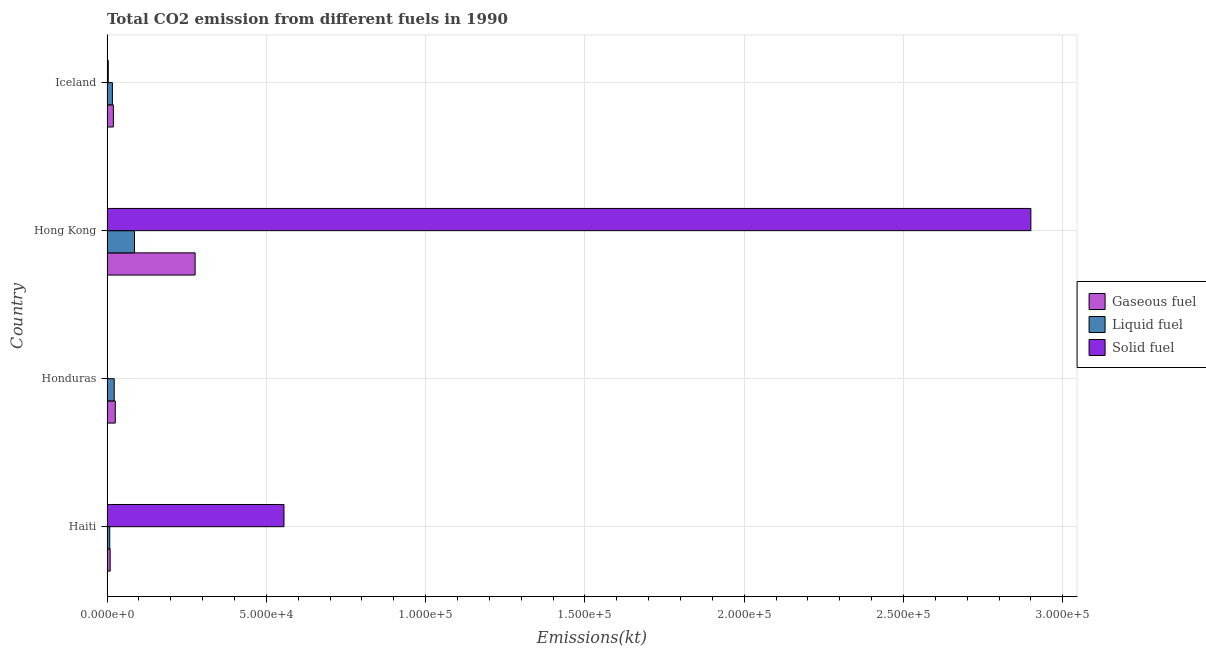How many different coloured bars are there?
Offer a terse response. 3. How many groups of bars are there?
Provide a succinct answer. 4. Are the number of bars on each tick of the Y-axis equal?
Offer a terse response. Yes. How many bars are there on the 3rd tick from the bottom?
Provide a succinct answer. 3. What is the label of the 1st group of bars from the top?
Provide a succinct answer. Iceland. What is the amount of co2 emissions from gaseous fuel in Honduras?
Your answer should be compact. 2592.57. Across all countries, what is the maximum amount of co2 emissions from liquid fuel?
Your answer should be compact. 8632.12. Across all countries, what is the minimum amount of co2 emissions from liquid fuel?
Ensure brevity in your answer.  861.75. In which country was the amount of co2 emissions from gaseous fuel maximum?
Your answer should be very brief. Hong Kong. In which country was the amount of co2 emissions from solid fuel minimum?
Your answer should be very brief. Honduras. What is the total amount of co2 emissions from solid fuel in the graph?
Provide a short and direct response. 3.46e+05. What is the difference between the amount of co2 emissions from gaseous fuel in Haiti and that in Hong Kong?
Offer a terse response. -2.67e+04. What is the difference between the amount of co2 emissions from liquid fuel in Honduras and the amount of co2 emissions from gaseous fuel in Haiti?
Offer a very short reply. 1272.45. What is the average amount of co2 emissions from solid fuel per country?
Provide a short and direct response. 8.65e+04. What is the difference between the amount of co2 emissions from liquid fuel and amount of co2 emissions from gaseous fuel in Haiti?
Your answer should be very brief. -132.01. What is the ratio of the amount of co2 emissions from gaseous fuel in Haiti to that in Honduras?
Your response must be concise. 0.38. Is the amount of co2 emissions from gaseous fuel in Haiti less than that in Hong Kong?
Your answer should be very brief. Yes. What is the difference between the highest and the second highest amount of co2 emissions from solid fuel?
Keep it short and to the point. 2.34e+05. What is the difference between the highest and the lowest amount of co2 emissions from liquid fuel?
Your response must be concise. 7770.37. In how many countries, is the amount of co2 emissions from solid fuel greater than the average amount of co2 emissions from solid fuel taken over all countries?
Ensure brevity in your answer.  1. What does the 1st bar from the top in Honduras represents?
Provide a succinct answer. Solid fuel. What does the 2nd bar from the bottom in Iceland represents?
Ensure brevity in your answer.  Liquid fuel. Is it the case that in every country, the sum of the amount of co2 emissions from gaseous fuel and amount of co2 emissions from liquid fuel is greater than the amount of co2 emissions from solid fuel?
Offer a terse response. No. How many bars are there?
Provide a short and direct response. 12. How many countries are there in the graph?
Offer a very short reply. 4. Are the values on the major ticks of X-axis written in scientific E-notation?
Provide a succinct answer. Yes. Does the graph contain grids?
Give a very brief answer. Yes. How are the legend labels stacked?
Keep it short and to the point. Vertical. What is the title of the graph?
Give a very brief answer. Total CO2 emission from different fuels in 1990. Does "Agriculture" appear as one of the legend labels in the graph?
Your answer should be very brief. No. What is the label or title of the X-axis?
Provide a succinct answer. Emissions(kt). What is the label or title of the Y-axis?
Ensure brevity in your answer.  Country. What is the Emissions(kt) in Gaseous fuel in Haiti?
Your answer should be very brief. 993.76. What is the Emissions(kt) in Liquid fuel in Haiti?
Make the answer very short. 861.75. What is the Emissions(kt) in Solid fuel in Haiti?
Offer a terse response. 5.56e+04. What is the Emissions(kt) of Gaseous fuel in Honduras?
Your response must be concise. 2592.57. What is the Emissions(kt) of Liquid fuel in Honduras?
Keep it short and to the point. 2266.21. What is the Emissions(kt) of Solid fuel in Honduras?
Offer a very short reply. 139.35. What is the Emissions(kt) of Gaseous fuel in Hong Kong?
Keep it short and to the point. 2.77e+04. What is the Emissions(kt) of Liquid fuel in Hong Kong?
Provide a succinct answer. 8632.12. What is the Emissions(kt) of Solid fuel in Hong Kong?
Keep it short and to the point. 2.90e+05. What is the Emissions(kt) in Gaseous fuel in Iceland?
Provide a succinct answer. 1998.52. What is the Emissions(kt) in Liquid fuel in Iceland?
Make the answer very short. 1694.15. What is the Emissions(kt) in Solid fuel in Iceland?
Ensure brevity in your answer.  403.37. Across all countries, what is the maximum Emissions(kt) of Gaseous fuel?
Ensure brevity in your answer.  2.77e+04. Across all countries, what is the maximum Emissions(kt) of Liquid fuel?
Make the answer very short. 8632.12. Across all countries, what is the maximum Emissions(kt) of Solid fuel?
Ensure brevity in your answer.  2.90e+05. Across all countries, what is the minimum Emissions(kt) in Gaseous fuel?
Ensure brevity in your answer.  993.76. Across all countries, what is the minimum Emissions(kt) in Liquid fuel?
Make the answer very short. 861.75. Across all countries, what is the minimum Emissions(kt) in Solid fuel?
Offer a very short reply. 139.35. What is the total Emissions(kt) of Gaseous fuel in the graph?
Your answer should be compact. 3.32e+04. What is the total Emissions(kt) of Liquid fuel in the graph?
Keep it short and to the point. 1.35e+04. What is the total Emissions(kt) in Solid fuel in the graph?
Your response must be concise. 3.46e+05. What is the difference between the Emissions(kt) in Gaseous fuel in Haiti and that in Honduras?
Provide a succinct answer. -1598.81. What is the difference between the Emissions(kt) in Liquid fuel in Haiti and that in Honduras?
Your response must be concise. -1404.46. What is the difference between the Emissions(kt) of Solid fuel in Haiti and that in Honduras?
Ensure brevity in your answer.  5.54e+04. What is the difference between the Emissions(kt) of Gaseous fuel in Haiti and that in Hong Kong?
Make the answer very short. -2.67e+04. What is the difference between the Emissions(kt) of Liquid fuel in Haiti and that in Hong Kong?
Make the answer very short. -7770.37. What is the difference between the Emissions(kt) in Solid fuel in Haiti and that in Hong Kong?
Offer a terse response. -2.34e+05. What is the difference between the Emissions(kt) of Gaseous fuel in Haiti and that in Iceland?
Your response must be concise. -1004.76. What is the difference between the Emissions(kt) in Liquid fuel in Haiti and that in Iceland?
Provide a short and direct response. -832.41. What is the difference between the Emissions(kt) in Solid fuel in Haiti and that in Iceland?
Your answer should be very brief. 5.51e+04. What is the difference between the Emissions(kt) in Gaseous fuel in Honduras and that in Hong Kong?
Your response must be concise. -2.51e+04. What is the difference between the Emissions(kt) of Liquid fuel in Honduras and that in Hong Kong?
Make the answer very short. -6365.91. What is the difference between the Emissions(kt) in Solid fuel in Honduras and that in Hong Kong?
Provide a succinct answer. -2.90e+05. What is the difference between the Emissions(kt) in Gaseous fuel in Honduras and that in Iceland?
Your answer should be very brief. 594.05. What is the difference between the Emissions(kt) of Liquid fuel in Honduras and that in Iceland?
Offer a terse response. 572.05. What is the difference between the Emissions(kt) in Solid fuel in Honduras and that in Iceland?
Ensure brevity in your answer.  -264.02. What is the difference between the Emissions(kt) of Gaseous fuel in Hong Kong and that in Iceland?
Ensure brevity in your answer.  2.57e+04. What is the difference between the Emissions(kt) in Liquid fuel in Hong Kong and that in Iceland?
Provide a short and direct response. 6937.96. What is the difference between the Emissions(kt) of Solid fuel in Hong Kong and that in Iceland?
Offer a terse response. 2.90e+05. What is the difference between the Emissions(kt) of Gaseous fuel in Haiti and the Emissions(kt) of Liquid fuel in Honduras?
Ensure brevity in your answer.  -1272.45. What is the difference between the Emissions(kt) in Gaseous fuel in Haiti and the Emissions(kt) in Solid fuel in Honduras?
Your answer should be very brief. 854.41. What is the difference between the Emissions(kt) in Liquid fuel in Haiti and the Emissions(kt) in Solid fuel in Honduras?
Ensure brevity in your answer.  722.4. What is the difference between the Emissions(kt) in Gaseous fuel in Haiti and the Emissions(kt) in Liquid fuel in Hong Kong?
Provide a succinct answer. -7638.36. What is the difference between the Emissions(kt) in Gaseous fuel in Haiti and the Emissions(kt) in Solid fuel in Hong Kong?
Offer a terse response. -2.89e+05. What is the difference between the Emissions(kt) in Liquid fuel in Haiti and the Emissions(kt) in Solid fuel in Hong Kong?
Ensure brevity in your answer.  -2.89e+05. What is the difference between the Emissions(kt) in Gaseous fuel in Haiti and the Emissions(kt) in Liquid fuel in Iceland?
Make the answer very short. -700.4. What is the difference between the Emissions(kt) of Gaseous fuel in Haiti and the Emissions(kt) of Solid fuel in Iceland?
Offer a very short reply. 590.39. What is the difference between the Emissions(kt) of Liquid fuel in Haiti and the Emissions(kt) of Solid fuel in Iceland?
Offer a very short reply. 458.38. What is the difference between the Emissions(kt) of Gaseous fuel in Honduras and the Emissions(kt) of Liquid fuel in Hong Kong?
Offer a very short reply. -6039.55. What is the difference between the Emissions(kt) in Gaseous fuel in Honduras and the Emissions(kt) in Solid fuel in Hong Kong?
Your answer should be compact. -2.87e+05. What is the difference between the Emissions(kt) of Liquid fuel in Honduras and the Emissions(kt) of Solid fuel in Hong Kong?
Make the answer very short. -2.88e+05. What is the difference between the Emissions(kt) of Gaseous fuel in Honduras and the Emissions(kt) of Liquid fuel in Iceland?
Give a very brief answer. 898.41. What is the difference between the Emissions(kt) in Gaseous fuel in Honduras and the Emissions(kt) in Solid fuel in Iceland?
Offer a terse response. 2189.2. What is the difference between the Emissions(kt) of Liquid fuel in Honduras and the Emissions(kt) of Solid fuel in Iceland?
Your response must be concise. 1862.84. What is the difference between the Emissions(kt) in Gaseous fuel in Hong Kong and the Emissions(kt) in Liquid fuel in Iceland?
Your answer should be very brief. 2.60e+04. What is the difference between the Emissions(kt) in Gaseous fuel in Hong Kong and the Emissions(kt) in Solid fuel in Iceland?
Your answer should be very brief. 2.73e+04. What is the difference between the Emissions(kt) of Liquid fuel in Hong Kong and the Emissions(kt) of Solid fuel in Iceland?
Keep it short and to the point. 8228.75. What is the average Emissions(kt) in Gaseous fuel per country?
Provide a short and direct response. 8311.26. What is the average Emissions(kt) in Liquid fuel per country?
Provide a succinct answer. 3363.56. What is the average Emissions(kt) in Solid fuel per country?
Ensure brevity in your answer.  8.65e+04. What is the difference between the Emissions(kt) in Gaseous fuel and Emissions(kt) in Liquid fuel in Haiti?
Provide a succinct answer. 132.01. What is the difference between the Emissions(kt) in Gaseous fuel and Emissions(kt) in Solid fuel in Haiti?
Offer a very short reply. -5.46e+04. What is the difference between the Emissions(kt) in Liquid fuel and Emissions(kt) in Solid fuel in Haiti?
Keep it short and to the point. -5.47e+04. What is the difference between the Emissions(kt) of Gaseous fuel and Emissions(kt) of Liquid fuel in Honduras?
Provide a succinct answer. 326.36. What is the difference between the Emissions(kt) in Gaseous fuel and Emissions(kt) in Solid fuel in Honduras?
Your answer should be very brief. 2453.22. What is the difference between the Emissions(kt) of Liquid fuel and Emissions(kt) of Solid fuel in Honduras?
Provide a succinct answer. 2126.86. What is the difference between the Emissions(kt) of Gaseous fuel and Emissions(kt) of Liquid fuel in Hong Kong?
Ensure brevity in your answer.  1.90e+04. What is the difference between the Emissions(kt) in Gaseous fuel and Emissions(kt) in Solid fuel in Hong Kong?
Make the answer very short. -2.62e+05. What is the difference between the Emissions(kt) of Liquid fuel and Emissions(kt) of Solid fuel in Hong Kong?
Offer a very short reply. -2.81e+05. What is the difference between the Emissions(kt) of Gaseous fuel and Emissions(kt) of Liquid fuel in Iceland?
Ensure brevity in your answer.  304.36. What is the difference between the Emissions(kt) of Gaseous fuel and Emissions(kt) of Solid fuel in Iceland?
Offer a very short reply. 1595.14. What is the difference between the Emissions(kt) in Liquid fuel and Emissions(kt) in Solid fuel in Iceland?
Make the answer very short. 1290.78. What is the ratio of the Emissions(kt) of Gaseous fuel in Haiti to that in Honduras?
Offer a terse response. 0.38. What is the ratio of the Emissions(kt) in Liquid fuel in Haiti to that in Honduras?
Ensure brevity in your answer.  0.38. What is the ratio of the Emissions(kt) of Solid fuel in Haiti to that in Honduras?
Provide a succinct answer. 398.66. What is the ratio of the Emissions(kt) in Gaseous fuel in Haiti to that in Hong Kong?
Ensure brevity in your answer.  0.04. What is the ratio of the Emissions(kt) in Liquid fuel in Haiti to that in Hong Kong?
Make the answer very short. 0.1. What is the ratio of the Emissions(kt) in Solid fuel in Haiti to that in Hong Kong?
Keep it short and to the point. 0.19. What is the ratio of the Emissions(kt) in Gaseous fuel in Haiti to that in Iceland?
Offer a very short reply. 0.5. What is the ratio of the Emissions(kt) in Liquid fuel in Haiti to that in Iceland?
Provide a succinct answer. 0.51. What is the ratio of the Emissions(kt) in Solid fuel in Haiti to that in Iceland?
Give a very brief answer. 137.72. What is the ratio of the Emissions(kt) in Gaseous fuel in Honduras to that in Hong Kong?
Ensure brevity in your answer.  0.09. What is the ratio of the Emissions(kt) in Liquid fuel in Honduras to that in Hong Kong?
Your answer should be very brief. 0.26. What is the ratio of the Emissions(kt) in Gaseous fuel in Honduras to that in Iceland?
Provide a short and direct response. 1.3. What is the ratio of the Emissions(kt) of Liquid fuel in Honduras to that in Iceland?
Your response must be concise. 1.34. What is the ratio of the Emissions(kt) in Solid fuel in Honduras to that in Iceland?
Provide a succinct answer. 0.35. What is the ratio of the Emissions(kt) in Gaseous fuel in Hong Kong to that in Iceland?
Provide a succinct answer. 13.84. What is the ratio of the Emissions(kt) of Liquid fuel in Hong Kong to that in Iceland?
Keep it short and to the point. 5.1. What is the ratio of the Emissions(kt) in Solid fuel in Hong Kong to that in Iceland?
Ensure brevity in your answer.  718.93. What is the difference between the highest and the second highest Emissions(kt) of Gaseous fuel?
Your answer should be compact. 2.51e+04. What is the difference between the highest and the second highest Emissions(kt) in Liquid fuel?
Keep it short and to the point. 6365.91. What is the difference between the highest and the second highest Emissions(kt) in Solid fuel?
Your answer should be very brief. 2.34e+05. What is the difference between the highest and the lowest Emissions(kt) of Gaseous fuel?
Give a very brief answer. 2.67e+04. What is the difference between the highest and the lowest Emissions(kt) in Liquid fuel?
Your response must be concise. 7770.37. What is the difference between the highest and the lowest Emissions(kt) of Solid fuel?
Ensure brevity in your answer.  2.90e+05. 